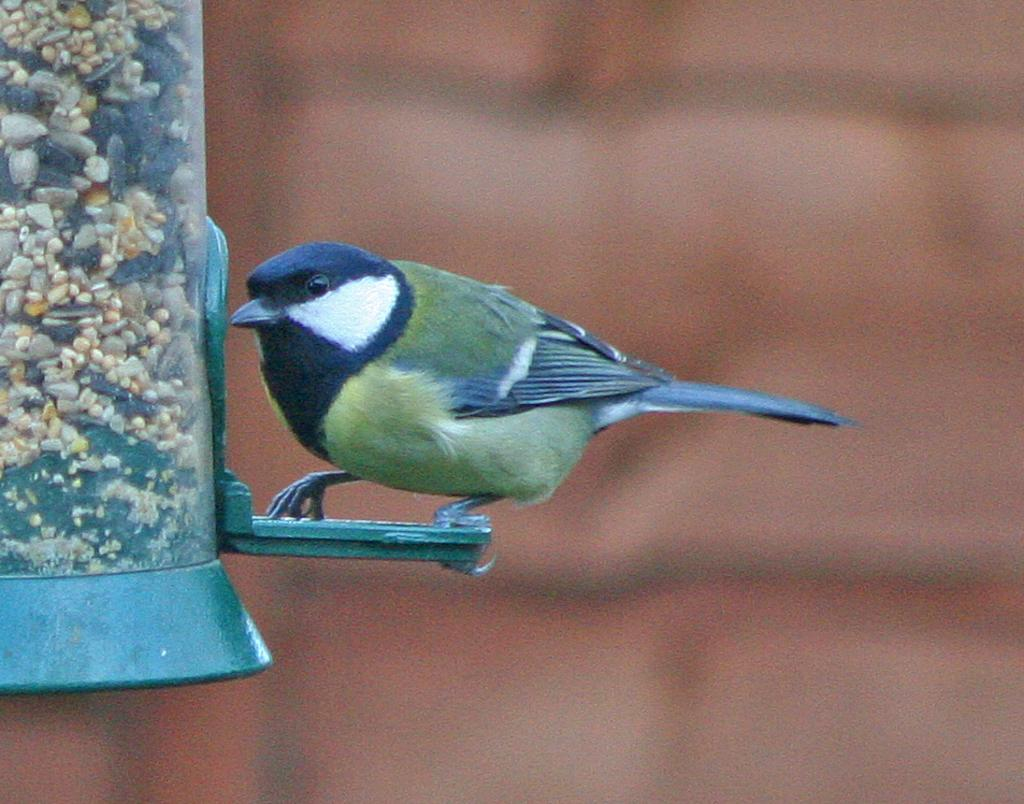What object is located on the left side of the image? There is a bird feeder on the left side of the image. What is on the bird feeder? There is a bird on the bird feeder. Can you describe the background of the image? The background of the image is blurred. What advice does the goose give to the bird on the bird feeder in the image? There is no goose present in the image, so it is not possible to answer that question. 